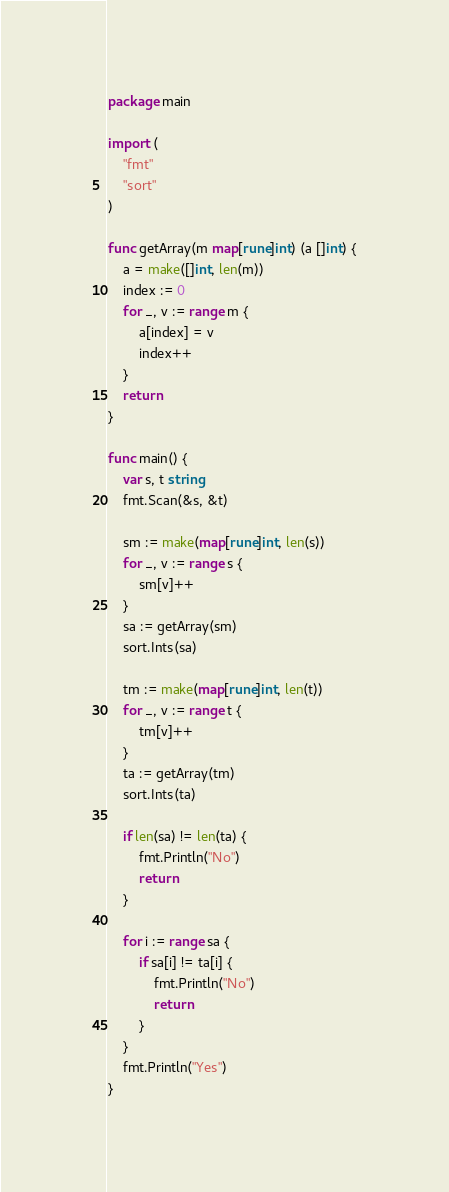Convert code to text. <code><loc_0><loc_0><loc_500><loc_500><_Go_>package main

import (
	"fmt"
	"sort"
)

func getArray(m map[rune]int) (a []int) {
	a = make([]int, len(m))
	index := 0
	for _, v := range m {
		a[index] = v
		index++
	}
	return
}

func main() {
	var s, t string
	fmt.Scan(&s, &t)

	sm := make(map[rune]int, len(s))
	for _, v := range s {
		sm[v]++
	}
	sa := getArray(sm)
	sort.Ints(sa)

	tm := make(map[rune]int, len(t))
	for _, v := range t {
		tm[v]++
	}
	ta := getArray(tm)
	sort.Ints(ta)

	if len(sa) != len(ta) {
		fmt.Println("No")
		return
	}

	for i := range sa {
		if sa[i] != ta[i] {
			fmt.Println("No")
			return
		}
	}
	fmt.Println("Yes")
}
</code> 